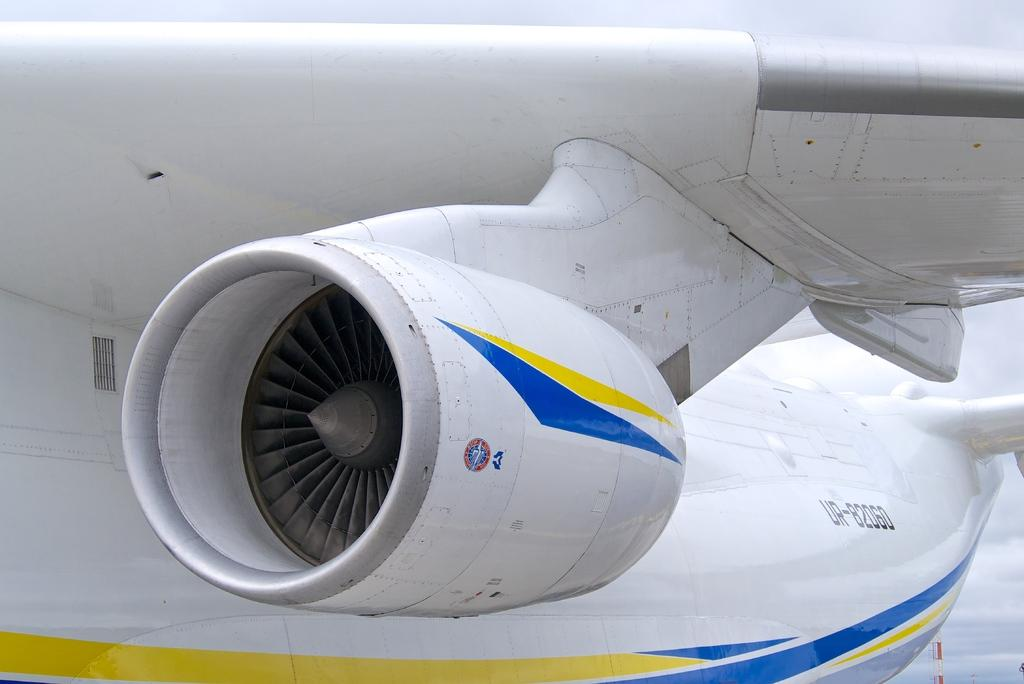What is the main subject of the image? The main subject of the image is a wing of an airplane. What can be seen in the background of the image? There is a tower and the sky visible in the background of the image. What type of beast can be seen climbing the tower in the image? There is no beast present in the image, and the tower is not being climbed by any creature. 